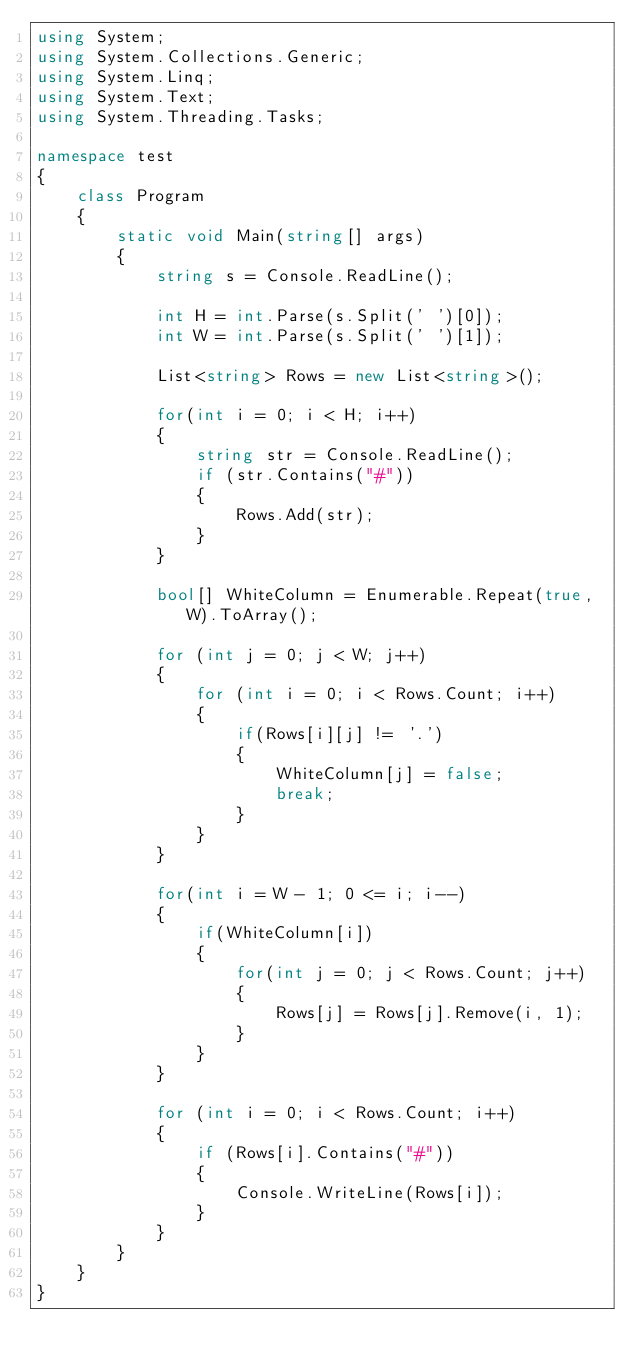<code> <loc_0><loc_0><loc_500><loc_500><_C#_>using System;
using System.Collections.Generic;
using System.Linq;
using System.Text;
using System.Threading.Tasks;

namespace test
{
    class Program
    {
        static void Main(string[] args)
        {
            string s = Console.ReadLine();

            int H = int.Parse(s.Split(' ')[0]);
            int W = int.Parse(s.Split(' ')[1]);

            List<string> Rows = new List<string>();

            for(int i = 0; i < H; i++)
            {
                string str = Console.ReadLine();
                if (str.Contains("#"))
                {
                    Rows.Add(str);
                } 
            }

            bool[] WhiteColumn = Enumerable.Repeat(true, W).ToArray();

            for (int j = 0; j < W; j++)
            {
                for (int i = 0; i < Rows.Count; i++)
                {
                    if(Rows[i][j] != '.')
                    {
                        WhiteColumn[j] = false;
                        break;
                    }
                }
            }

            for(int i = W - 1; 0 <= i; i--)
            {
                if(WhiteColumn[i])
                {
                    for(int j = 0; j < Rows.Count; j++)
                    {
                        Rows[j] = Rows[j].Remove(i, 1);
                    }
                }
            }

            for (int i = 0; i < Rows.Count; i++)
            {
                if (Rows[i].Contains("#"))
                {
                    Console.WriteLine(Rows[i]);
                }
            }
        }
    }
}
</code> 